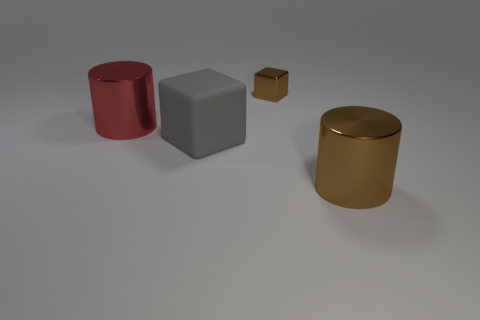Subtract all gray cubes. How many gray cylinders are left? 0 Add 2 red objects. How many red objects exist? 3 Add 3 large gray rubber cylinders. How many objects exist? 7 Subtract 1 red cylinders. How many objects are left? 3 Subtract all brown cylinders. Subtract all cyan cubes. How many cylinders are left? 1 Subtract all big shiny cylinders. Subtract all big metallic objects. How many objects are left? 0 Add 4 brown cylinders. How many brown cylinders are left? 5 